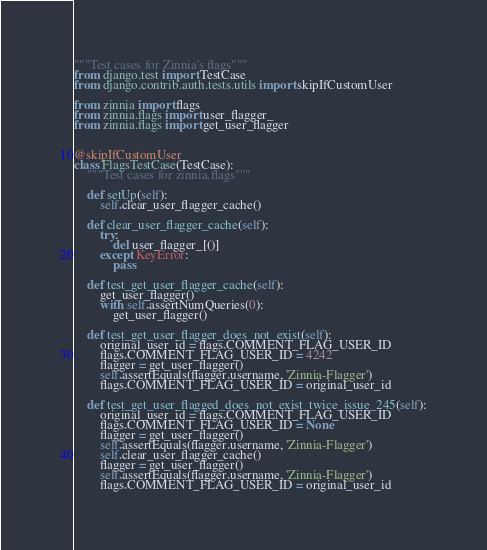Convert code to text. <code><loc_0><loc_0><loc_500><loc_500><_Python_>"""Test cases for Zinnia's flags"""
from django.test import TestCase
from django.contrib.auth.tests.utils import skipIfCustomUser

from zinnia import flags
from zinnia.flags import user_flagger_
from zinnia.flags import get_user_flagger


@skipIfCustomUser
class FlagsTestCase(TestCase):
    """Test cases for zinnia.flags"""

    def setUp(self):
        self.clear_user_flagger_cache()

    def clear_user_flagger_cache(self):
        try:
            del user_flagger_[()]
        except KeyError:
            pass

    def test_get_user_flagger_cache(self):
        get_user_flagger()
        with self.assertNumQueries(0):
            get_user_flagger()

    def test_get_user_flagger_does_not_exist(self):
        original_user_id = flags.COMMENT_FLAG_USER_ID
        flags.COMMENT_FLAG_USER_ID = 4242
        flagger = get_user_flagger()
        self.assertEquals(flagger.username, 'Zinnia-Flagger')
        flags.COMMENT_FLAG_USER_ID = original_user_id

    def test_get_user_flagged_does_not_exist_twice_issue_245(self):
        original_user_id = flags.COMMENT_FLAG_USER_ID
        flags.COMMENT_FLAG_USER_ID = None
        flagger = get_user_flagger()
        self.assertEquals(flagger.username, 'Zinnia-Flagger')
        self.clear_user_flagger_cache()
        flagger = get_user_flagger()
        self.assertEquals(flagger.username, 'Zinnia-Flagger')
        flags.COMMENT_FLAG_USER_ID = original_user_id
</code> 